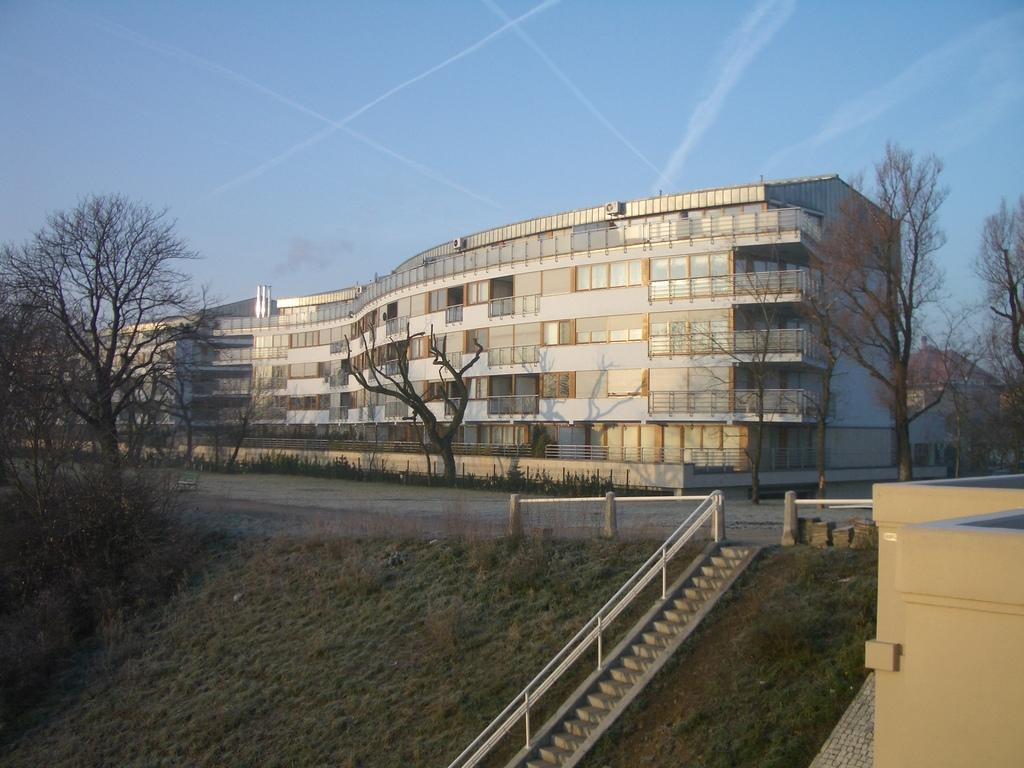What can be seen on the left side of the image? There are trees on a slope area on the left side of the image. What architectural feature is present on the right side of the image? There are stairs and a railing on the right side of the image. What is visible in the background of the image? There is a road, trees, a building, and the sky visible in the background of the image. What type of curtain is hanging in the background of the image? There is no curtain present in the image. How many parcels can be seen on the stairs in the image? There are no parcels visible in the image; only stairs and a railing are present on the right side. 